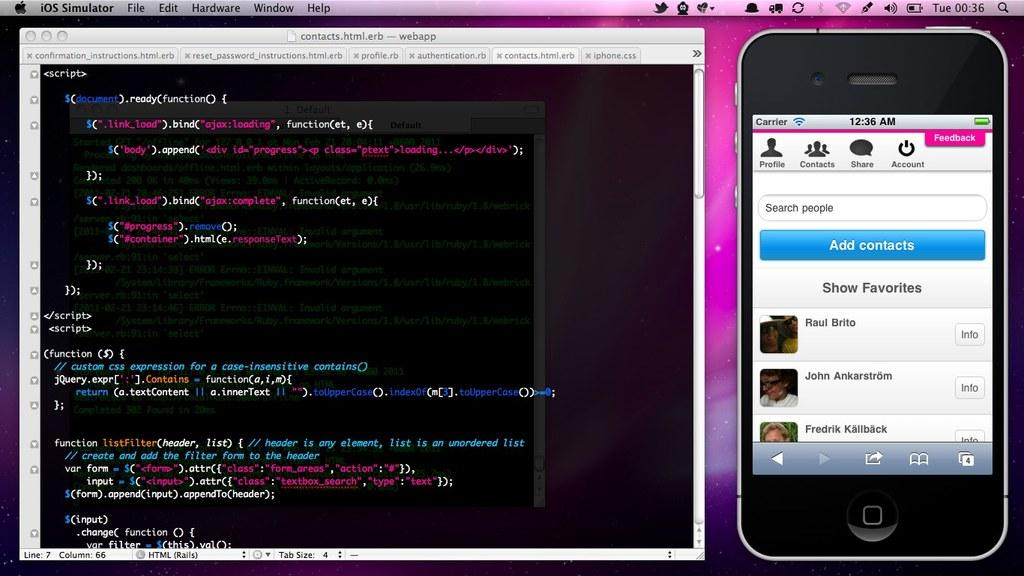<image>
Summarize the visual content of the image. A monitor on the left shows the codes for the contacts.html.erb as the smartphone shows the contacts app. 